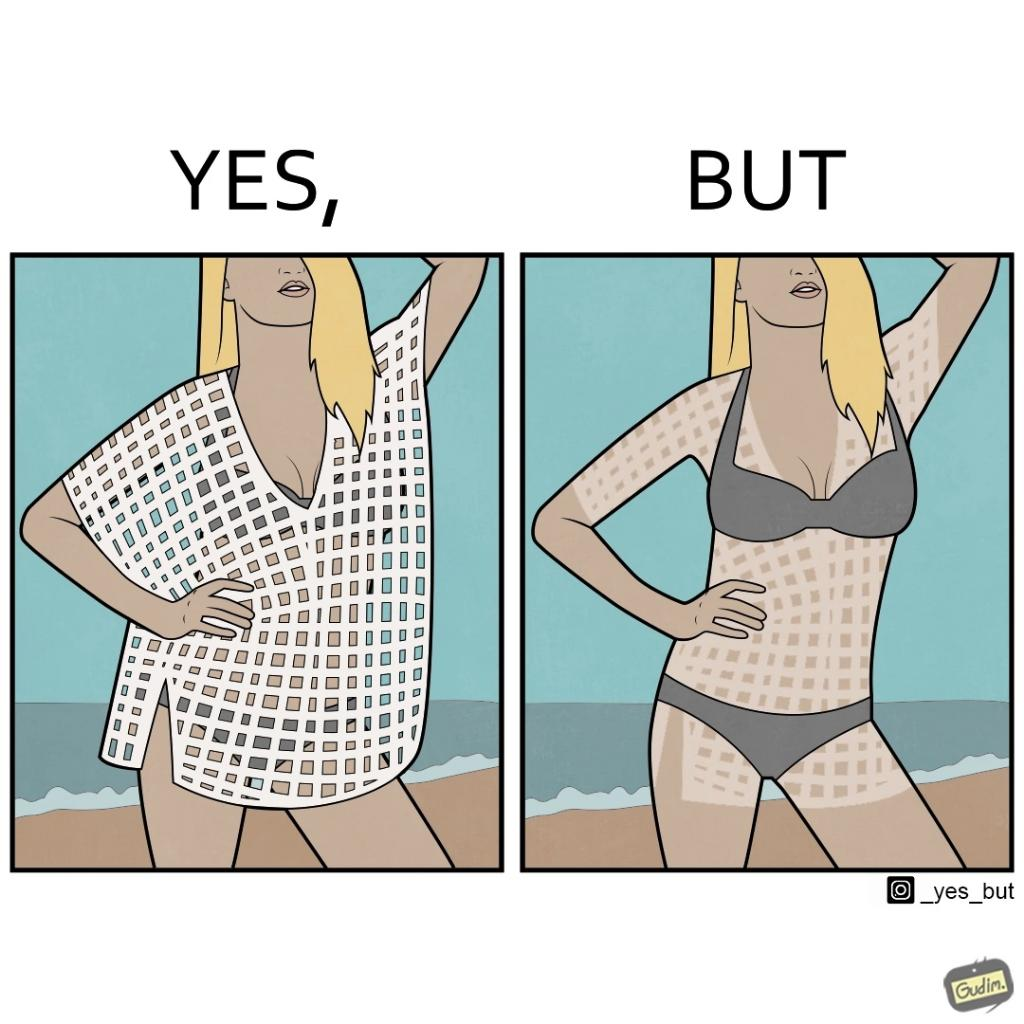What is shown in this image? Women wear netted tops while out in the sun on the beach as a beachwear, but when the person removes it, the skin is tanned in the same netted pattern looks weird, and goes against the purpose of using it as beachwear 